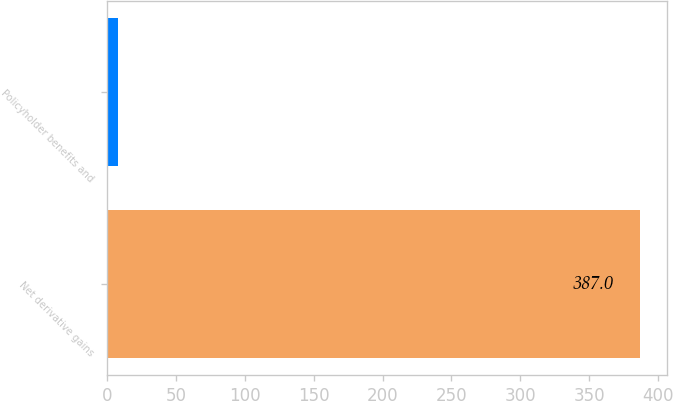Convert chart. <chart><loc_0><loc_0><loc_500><loc_500><bar_chart><fcel>Net derivative gains<fcel>Policyholder benefits and<nl><fcel>387<fcel>8<nl></chart> 